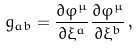Convert formula to latex. <formula><loc_0><loc_0><loc_500><loc_500>g _ { a b } = \frac { \partial \varphi ^ { \mu } } { \partial \xi ^ { a } } \frac { \partial \varphi ^ { \mu } } { \partial \xi ^ { b } } \, ,</formula> 